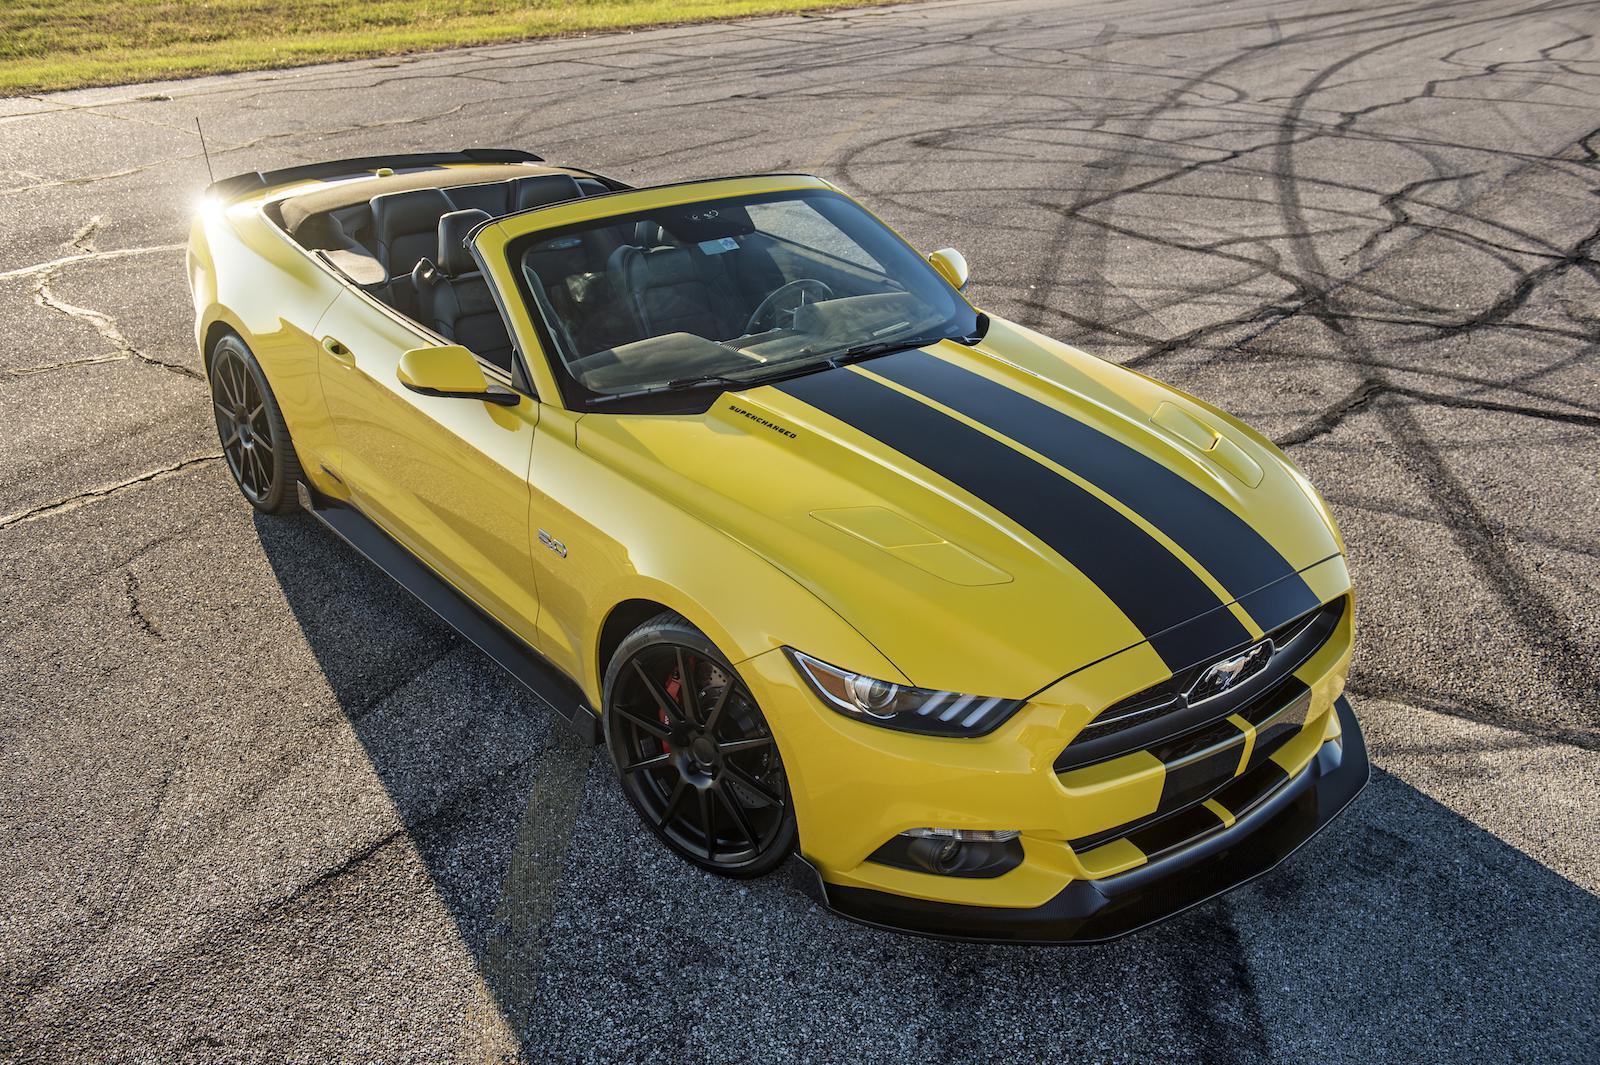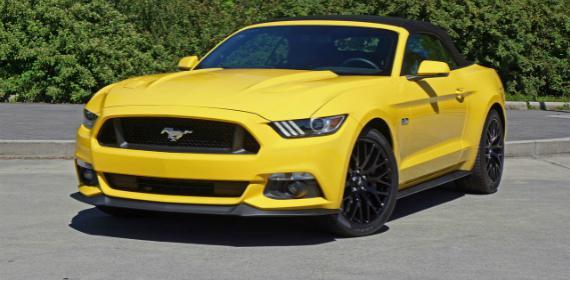The first image is the image on the left, the second image is the image on the right. Evaluate the accuracy of this statement regarding the images: "Black stripes are visible on the hood of a yellow convertible aimed rightward.". Is it true? Answer yes or no. Yes. The first image is the image on the left, the second image is the image on the right. Examine the images to the left and right. Is the description "One image shows a leftward-angled yellow convertible without a hood stripe, and the other features a right-turned convertible with black stripes on its hood." accurate? Answer yes or no. Yes. The first image is the image on the left, the second image is the image on the right. For the images shown, is this caption "The right image contains one yellow car that is facing towards the right." true? Answer yes or no. No. The first image is the image on the left, the second image is the image on the right. Assess this claim about the two images: "There are two yellow convertibles facing to the right.". Correct or not? Answer yes or no. No. 